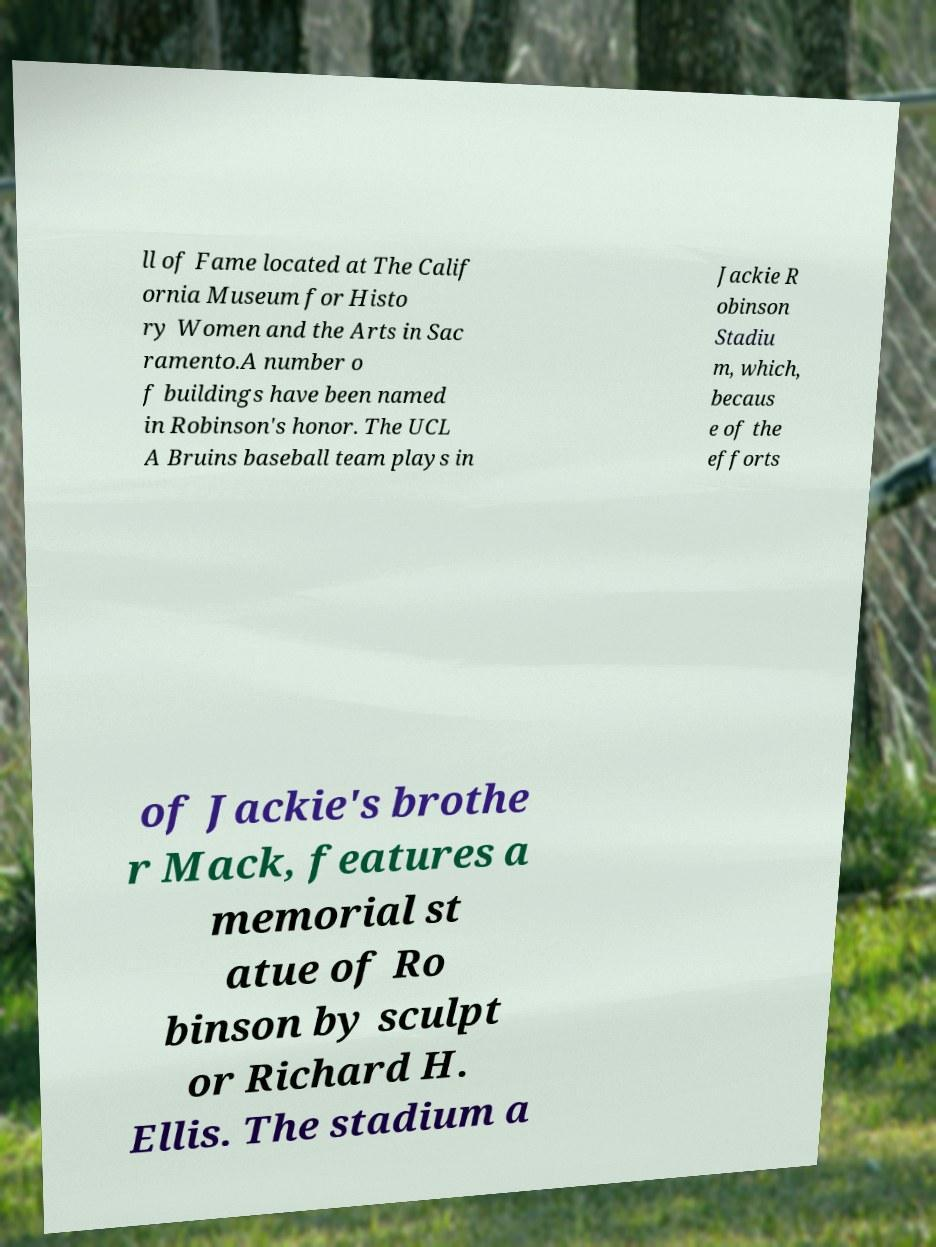What messages or text are displayed in this image? I need them in a readable, typed format. ll of Fame located at The Calif ornia Museum for Histo ry Women and the Arts in Sac ramento.A number o f buildings have been named in Robinson's honor. The UCL A Bruins baseball team plays in Jackie R obinson Stadiu m, which, becaus e of the efforts of Jackie's brothe r Mack, features a memorial st atue of Ro binson by sculpt or Richard H. Ellis. The stadium a 